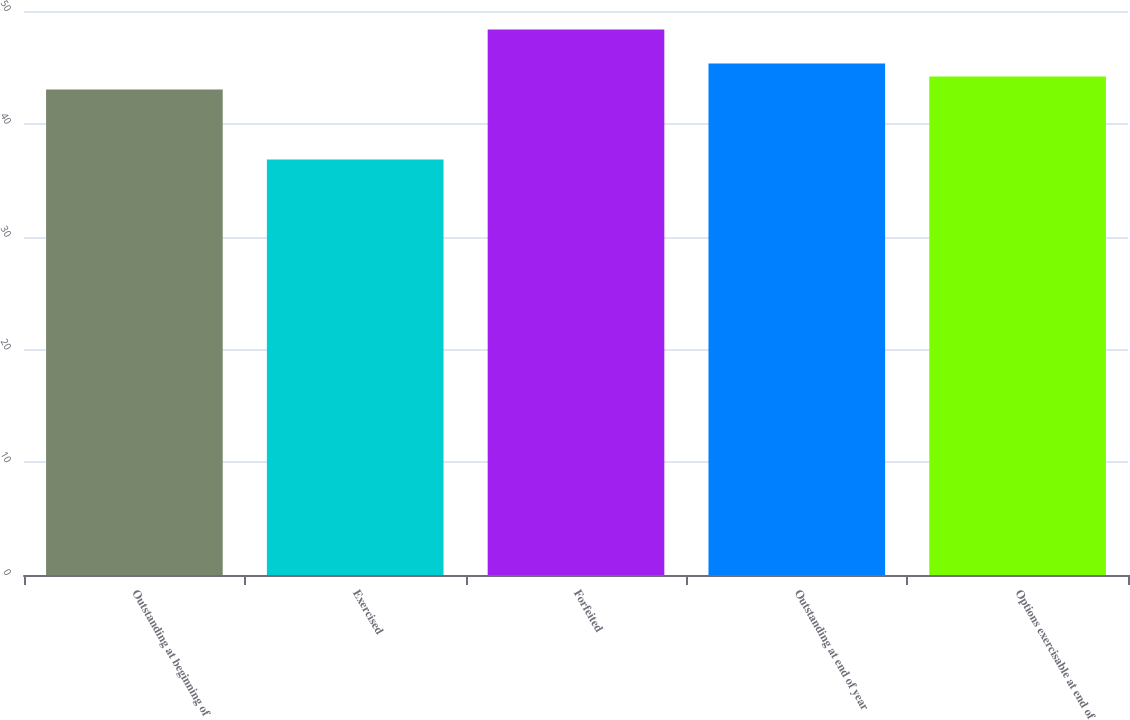Convert chart. <chart><loc_0><loc_0><loc_500><loc_500><bar_chart><fcel>Outstanding at beginning of<fcel>Exercised<fcel>Forfeited<fcel>Outstanding at end of year<fcel>Options exercisable at end of<nl><fcel>43.05<fcel>36.84<fcel>48.35<fcel>45.35<fcel>44.2<nl></chart> 